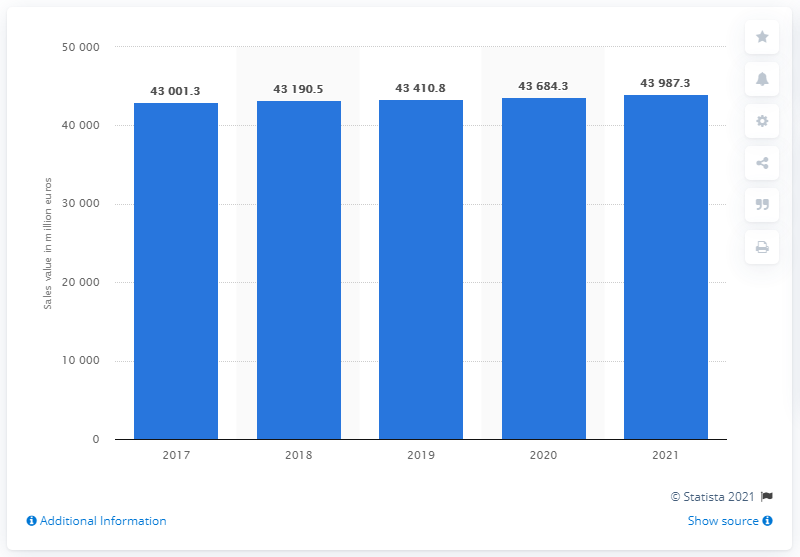List a handful of essential elements in this visual. In 2017, the sales value of supermarkets in Italy was 43,410.8 million euros. The estimated sales value of supermarkets in Italy in 2021 is 43,987.3. 